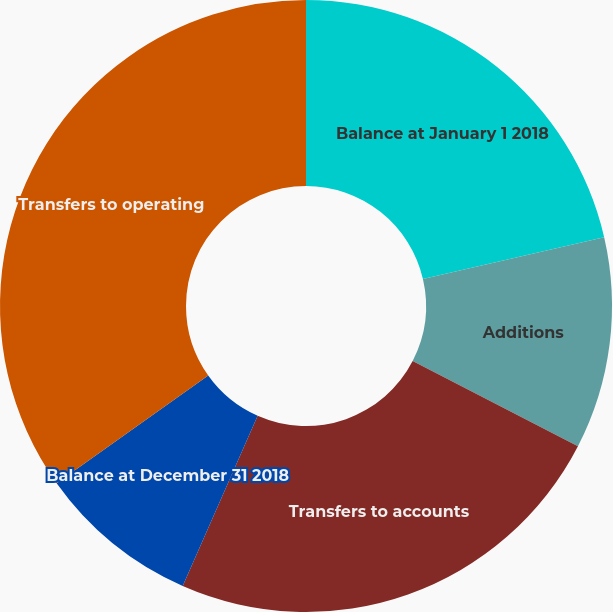<chart> <loc_0><loc_0><loc_500><loc_500><pie_chart><fcel>Balance at January 1 2018<fcel>Additions<fcel>Transfers to accounts<fcel>Balance at December 31 2018<fcel>Transfers to operating<nl><fcel>21.39%<fcel>11.19%<fcel>24.02%<fcel>8.56%<fcel>34.84%<nl></chart> 